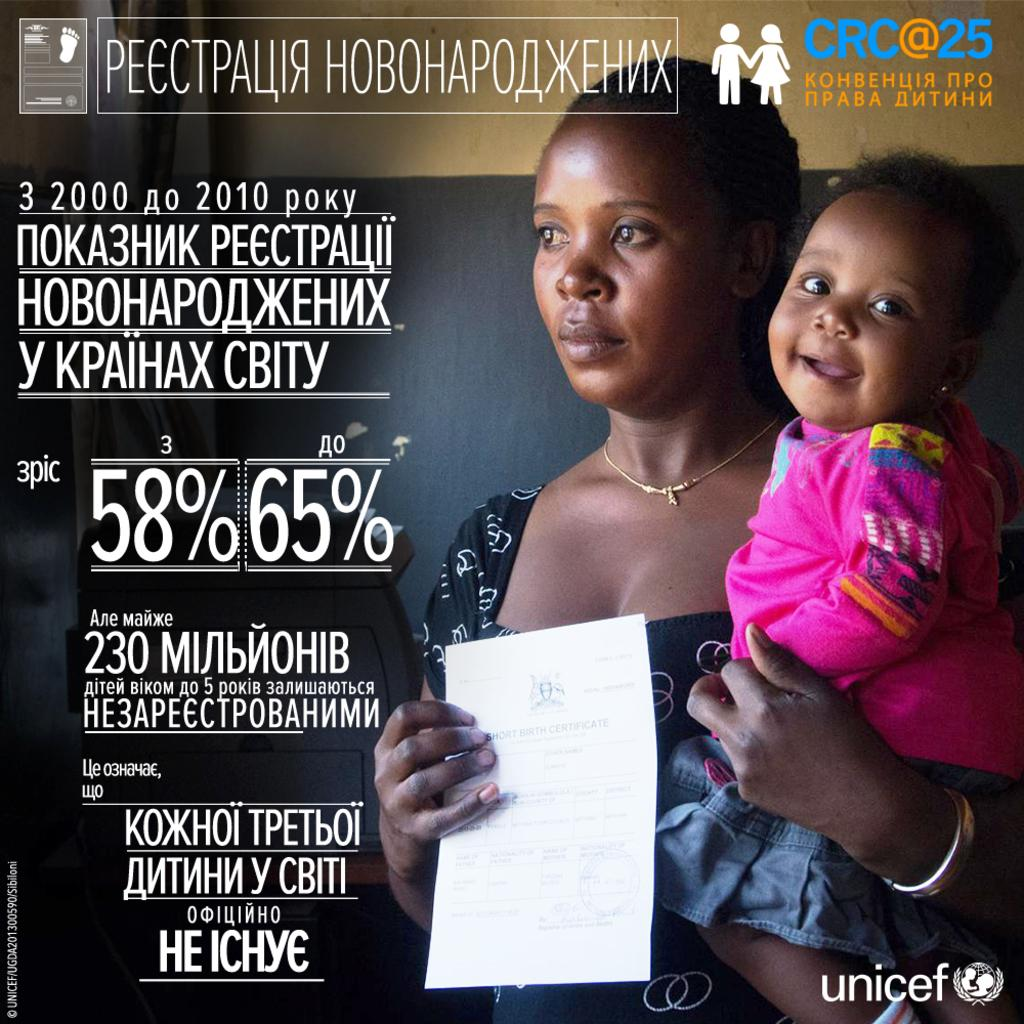What type of visual is depicted in the image? The image appears to be a poster. What can be found on the poster besides the visual elements? There is text on the poster. Who can be seen on the right side of the poster? There is a woman and a child on the right side of the poster. What is the woman holding in the image? The woman is holding a certificate. What is visible in the background of the poster? There is a well in the background of the poster. What route does the story take in the image? There is no story present in the image, as it is a poster featuring a woman, a child, and a well. What wish is granted to the child in the image? There is no wish granted to the child in the image, as it is a poster featuring a woman, a child, and a well. 